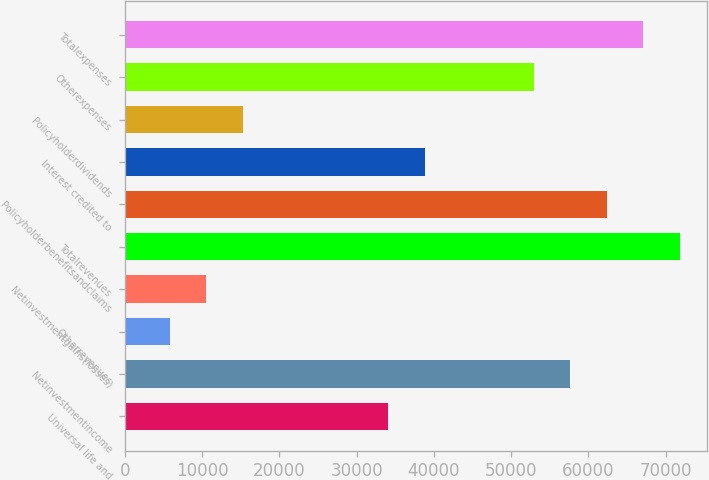<chart> <loc_0><loc_0><loc_500><loc_500><bar_chart><fcel>Universal life and<fcel>Netinvestmentincome<fcel>Otherrevenues<fcel>Netinvestmentgains(losses)<fcel>Totalrevenues<fcel>Policyholderbenefitsandclaims<fcel>Interest credited to<fcel>Policyholderdividends<fcel>Otherexpenses<fcel>Totalexpenses<nl><fcel>34106.9<fcel>57685.4<fcel>5812.7<fcel>10528.4<fcel>71832.5<fcel>62401.1<fcel>38822.6<fcel>15244.1<fcel>52969.7<fcel>67116.8<nl></chart> 